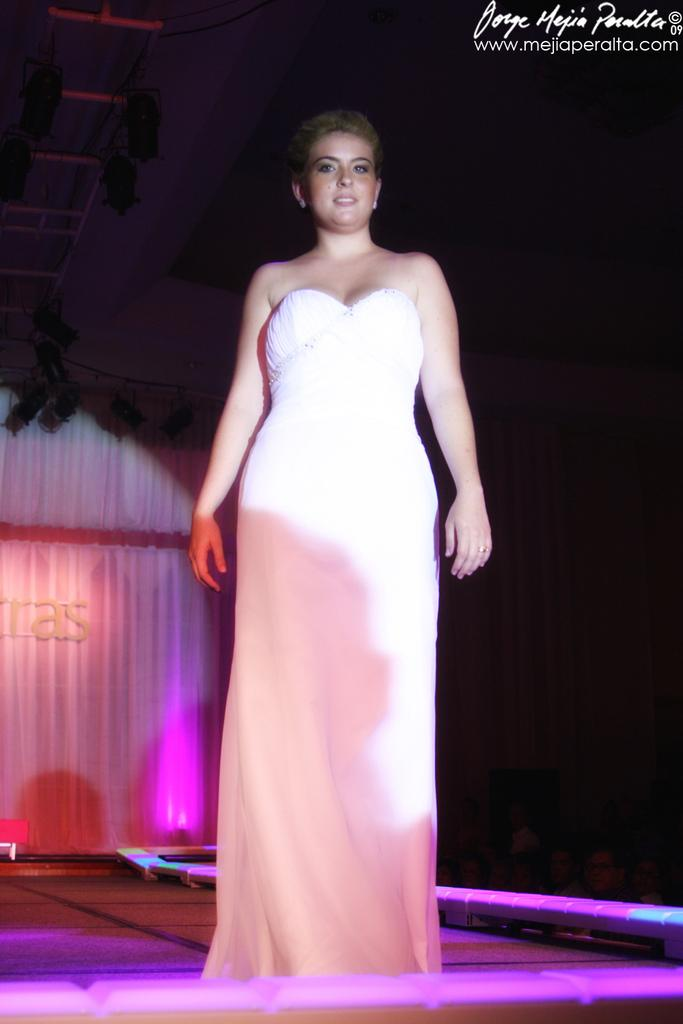Who is the main subject in the image? There is a woman in the image. Where is the woman located in the image? The woman is standing on a stage. What is the woman wearing in the image? The woman is wearing a white dress. What can be seen in the background of the image? There is a curtain in the image. What color is the curtain? The curtain is white in color. What is special about the lighting on the curtain? There is a pink color light focused on the curtain. What type of pickle is being served on the bed in the image? There is no bed or pickle present in the image. 